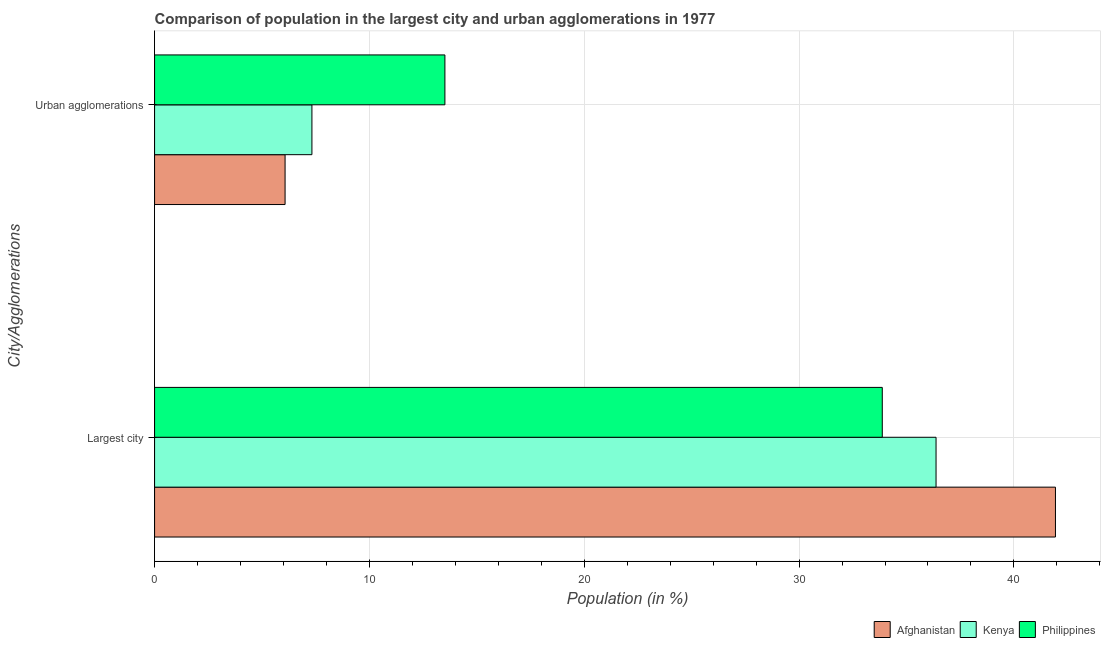How many different coloured bars are there?
Keep it short and to the point. 3. How many groups of bars are there?
Offer a terse response. 2. Are the number of bars per tick equal to the number of legend labels?
Offer a very short reply. Yes. What is the label of the 1st group of bars from the top?
Make the answer very short. Urban agglomerations. What is the population in urban agglomerations in Kenya?
Give a very brief answer. 7.32. Across all countries, what is the maximum population in urban agglomerations?
Provide a short and direct response. 13.51. Across all countries, what is the minimum population in the largest city?
Your answer should be very brief. 33.87. In which country was the population in urban agglomerations maximum?
Your answer should be compact. Philippines. What is the total population in urban agglomerations in the graph?
Give a very brief answer. 26.91. What is the difference between the population in the largest city in Philippines and that in Kenya?
Offer a very short reply. -2.5. What is the difference between the population in urban agglomerations in Kenya and the population in the largest city in Philippines?
Offer a very short reply. -26.55. What is the average population in the largest city per country?
Provide a succinct answer. 37.39. What is the difference between the population in the largest city and population in urban agglomerations in Kenya?
Your answer should be compact. 29.05. In how many countries, is the population in urban agglomerations greater than 42 %?
Give a very brief answer. 0. What is the ratio of the population in the largest city in Kenya to that in Afghanistan?
Provide a succinct answer. 0.87. Is the population in the largest city in Philippines less than that in Kenya?
Ensure brevity in your answer.  Yes. In how many countries, is the population in urban agglomerations greater than the average population in urban agglomerations taken over all countries?
Offer a very short reply. 1. What does the 2nd bar from the bottom in Urban agglomerations represents?
Your answer should be compact. Kenya. How many countries are there in the graph?
Make the answer very short. 3. Are the values on the major ticks of X-axis written in scientific E-notation?
Provide a succinct answer. No. Does the graph contain any zero values?
Your response must be concise. No. How many legend labels are there?
Make the answer very short. 3. What is the title of the graph?
Your answer should be compact. Comparison of population in the largest city and urban agglomerations in 1977. What is the label or title of the Y-axis?
Provide a short and direct response. City/Agglomerations. What is the Population (in %) in Afghanistan in Largest city?
Provide a short and direct response. 41.93. What is the Population (in %) of Kenya in Largest city?
Provide a short and direct response. 36.38. What is the Population (in %) of Philippines in Largest city?
Your response must be concise. 33.87. What is the Population (in %) in Afghanistan in Urban agglomerations?
Ensure brevity in your answer.  6.07. What is the Population (in %) of Kenya in Urban agglomerations?
Ensure brevity in your answer.  7.32. What is the Population (in %) of Philippines in Urban agglomerations?
Your response must be concise. 13.51. Across all City/Agglomerations, what is the maximum Population (in %) of Afghanistan?
Offer a very short reply. 41.93. Across all City/Agglomerations, what is the maximum Population (in %) of Kenya?
Provide a succinct answer. 36.38. Across all City/Agglomerations, what is the maximum Population (in %) of Philippines?
Provide a succinct answer. 33.87. Across all City/Agglomerations, what is the minimum Population (in %) of Afghanistan?
Your answer should be very brief. 6.07. Across all City/Agglomerations, what is the minimum Population (in %) of Kenya?
Offer a very short reply. 7.32. Across all City/Agglomerations, what is the minimum Population (in %) in Philippines?
Your answer should be compact. 13.51. What is the total Population (in %) in Afghanistan in the graph?
Give a very brief answer. 48.01. What is the total Population (in %) in Kenya in the graph?
Your answer should be compact. 43.7. What is the total Population (in %) in Philippines in the graph?
Your answer should be very brief. 47.39. What is the difference between the Population (in %) of Afghanistan in Largest city and that in Urban agglomerations?
Offer a very short reply. 35.86. What is the difference between the Population (in %) in Kenya in Largest city and that in Urban agglomerations?
Keep it short and to the point. 29.05. What is the difference between the Population (in %) of Philippines in Largest city and that in Urban agglomerations?
Ensure brevity in your answer.  20.36. What is the difference between the Population (in %) of Afghanistan in Largest city and the Population (in %) of Kenya in Urban agglomerations?
Your response must be concise. 34.61. What is the difference between the Population (in %) in Afghanistan in Largest city and the Population (in %) in Philippines in Urban agglomerations?
Offer a terse response. 28.42. What is the difference between the Population (in %) in Kenya in Largest city and the Population (in %) in Philippines in Urban agglomerations?
Provide a succinct answer. 22.86. What is the average Population (in %) of Afghanistan per City/Agglomerations?
Provide a short and direct response. 24. What is the average Population (in %) in Kenya per City/Agglomerations?
Ensure brevity in your answer.  21.85. What is the average Population (in %) in Philippines per City/Agglomerations?
Your response must be concise. 23.69. What is the difference between the Population (in %) of Afghanistan and Population (in %) of Kenya in Largest city?
Your answer should be very brief. 5.56. What is the difference between the Population (in %) in Afghanistan and Population (in %) in Philippines in Largest city?
Your response must be concise. 8.06. What is the difference between the Population (in %) of Kenya and Population (in %) of Philippines in Largest city?
Provide a succinct answer. 2.5. What is the difference between the Population (in %) of Afghanistan and Population (in %) of Kenya in Urban agglomerations?
Your answer should be very brief. -1.25. What is the difference between the Population (in %) of Afghanistan and Population (in %) of Philippines in Urban agglomerations?
Your answer should be very brief. -7.44. What is the difference between the Population (in %) of Kenya and Population (in %) of Philippines in Urban agglomerations?
Your response must be concise. -6.19. What is the ratio of the Population (in %) of Afghanistan in Largest city to that in Urban agglomerations?
Offer a very short reply. 6.9. What is the ratio of the Population (in %) in Kenya in Largest city to that in Urban agglomerations?
Offer a very short reply. 4.97. What is the ratio of the Population (in %) of Philippines in Largest city to that in Urban agglomerations?
Provide a short and direct response. 2.51. What is the difference between the highest and the second highest Population (in %) of Afghanistan?
Ensure brevity in your answer.  35.86. What is the difference between the highest and the second highest Population (in %) in Kenya?
Provide a short and direct response. 29.05. What is the difference between the highest and the second highest Population (in %) in Philippines?
Give a very brief answer. 20.36. What is the difference between the highest and the lowest Population (in %) of Afghanistan?
Provide a short and direct response. 35.86. What is the difference between the highest and the lowest Population (in %) of Kenya?
Your answer should be very brief. 29.05. What is the difference between the highest and the lowest Population (in %) of Philippines?
Provide a succinct answer. 20.36. 